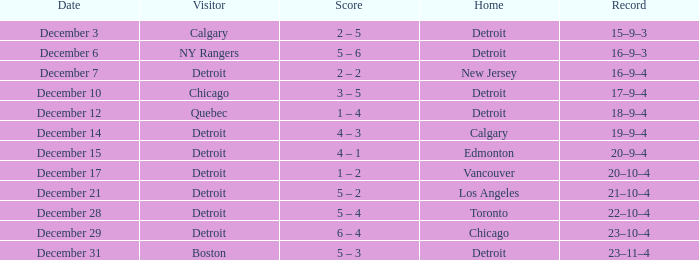Who is the attendee on december 3? Calgary. 